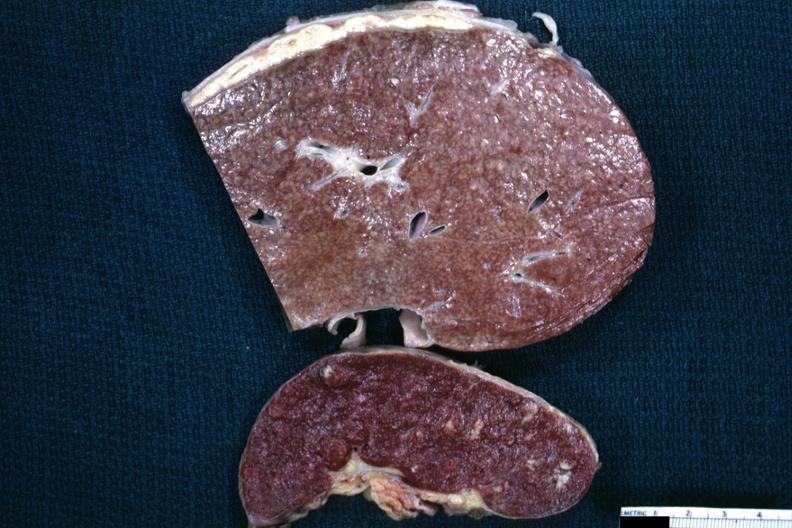what does this image show?
Answer the question using a single word or phrase. Slices of liver and spleen typical tuberculous exudate is present on capsule of liver and spleen contains granulomata slide is a close-up view of the typical cold abscess exudate on the liver surface 